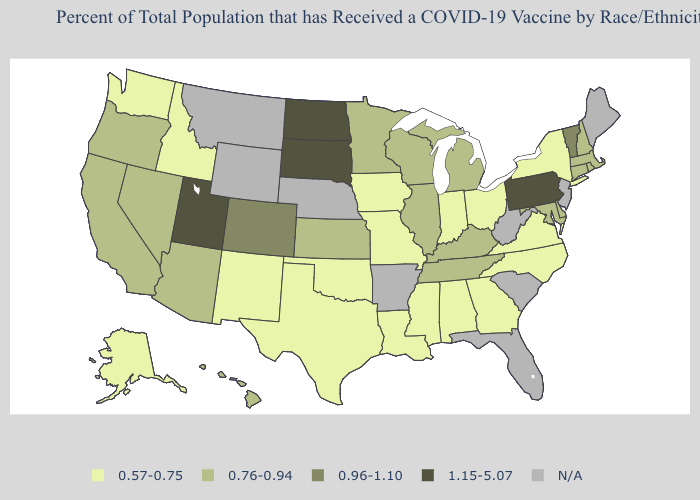Does New Hampshire have the lowest value in the Northeast?
Write a very short answer. No. What is the value of Idaho?
Concise answer only. 0.57-0.75. Which states have the lowest value in the South?
Concise answer only. Alabama, Georgia, Louisiana, Mississippi, North Carolina, Oklahoma, Texas, Virginia. What is the value of Kansas?
Be succinct. 0.76-0.94. Among the states that border Texas , which have the lowest value?
Short answer required. Louisiana, New Mexico, Oklahoma. What is the highest value in states that border Pennsylvania?
Short answer required. 0.76-0.94. How many symbols are there in the legend?
Be succinct. 5. Does the map have missing data?
Quick response, please. Yes. Does the first symbol in the legend represent the smallest category?
Concise answer only. Yes. Which states hav the highest value in the Northeast?
Keep it brief. Pennsylvania. What is the value of Kentucky?
Quick response, please. 0.76-0.94. Does Georgia have the lowest value in the USA?
Concise answer only. Yes. What is the value of Tennessee?
Write a very short answer. 0.76-0.94. How many symbols are there in the legend?
Quick response, please. 5. Name the states that have a value in the range 1.15-5.07?
Concise answer only. North Dakota, Pennsylvania, South Dakota, Utah. 